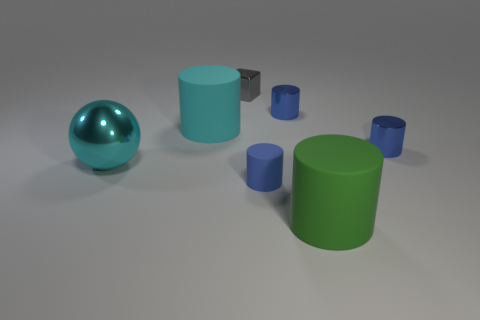There is a small gray shiny thing; are there any small things in front of it?
Provide a succinct answer. Yes. What is the material of the big cylinder to the right of the big matte cylinder behind the blue rubber thing?
Provide a succinct answer. Rubber. What size is the cyan matte object that is the same shape as the blue matte object?
Your response must be concise. Large. There is a metal object that is in front of the tiny gray metallic object and on the left side of the tiny rubber cylinder; what color is it?
Offer a very short reply. Cyan. Is the size of the matte cylinder that is left of the gray cube the same as the large green cylinder?
Your answer should be compact. Yes. Are there any other things that are the same shape as the cyan metallic object?
Your answer should be very brief. No. Are the small gray block and the small blue thing that is behind the cyan matte cylinder made of the same material?
Make the answer very short. Yes. What number of purple things are rubber objects or large rubber things?
Provide a short and direct response. 0. Are there any brown rubber blocks?
Your response must be concise. No. There is a blue metallic object behind the big cylinder that is behind the big green cylinder; is there a big cyan ball left of it?
Keep it short and to the point. Yes. 